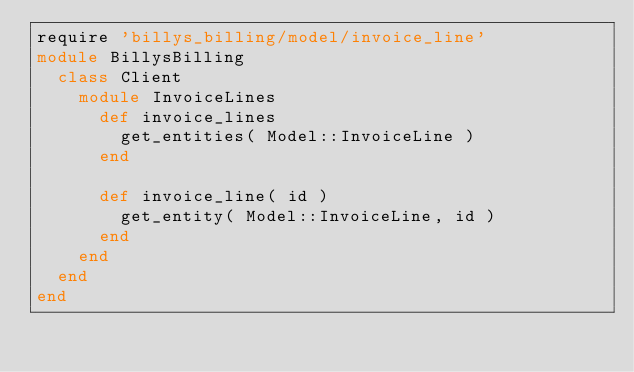Convert code to text. <code><loc_0><loc_0><loc_500><loc_500><_Ruby_>require 'billys_billing/model/invoice_line'
module BillysBilling
  class Client
    module InvoiceLines
      def invoice_lines
        get_entities( Model::InvoiceLine )
      end

      def invoice_line( id )
        get_entity( Model::InvoiceLine, id )
      end
    end
  end
end
</code> 